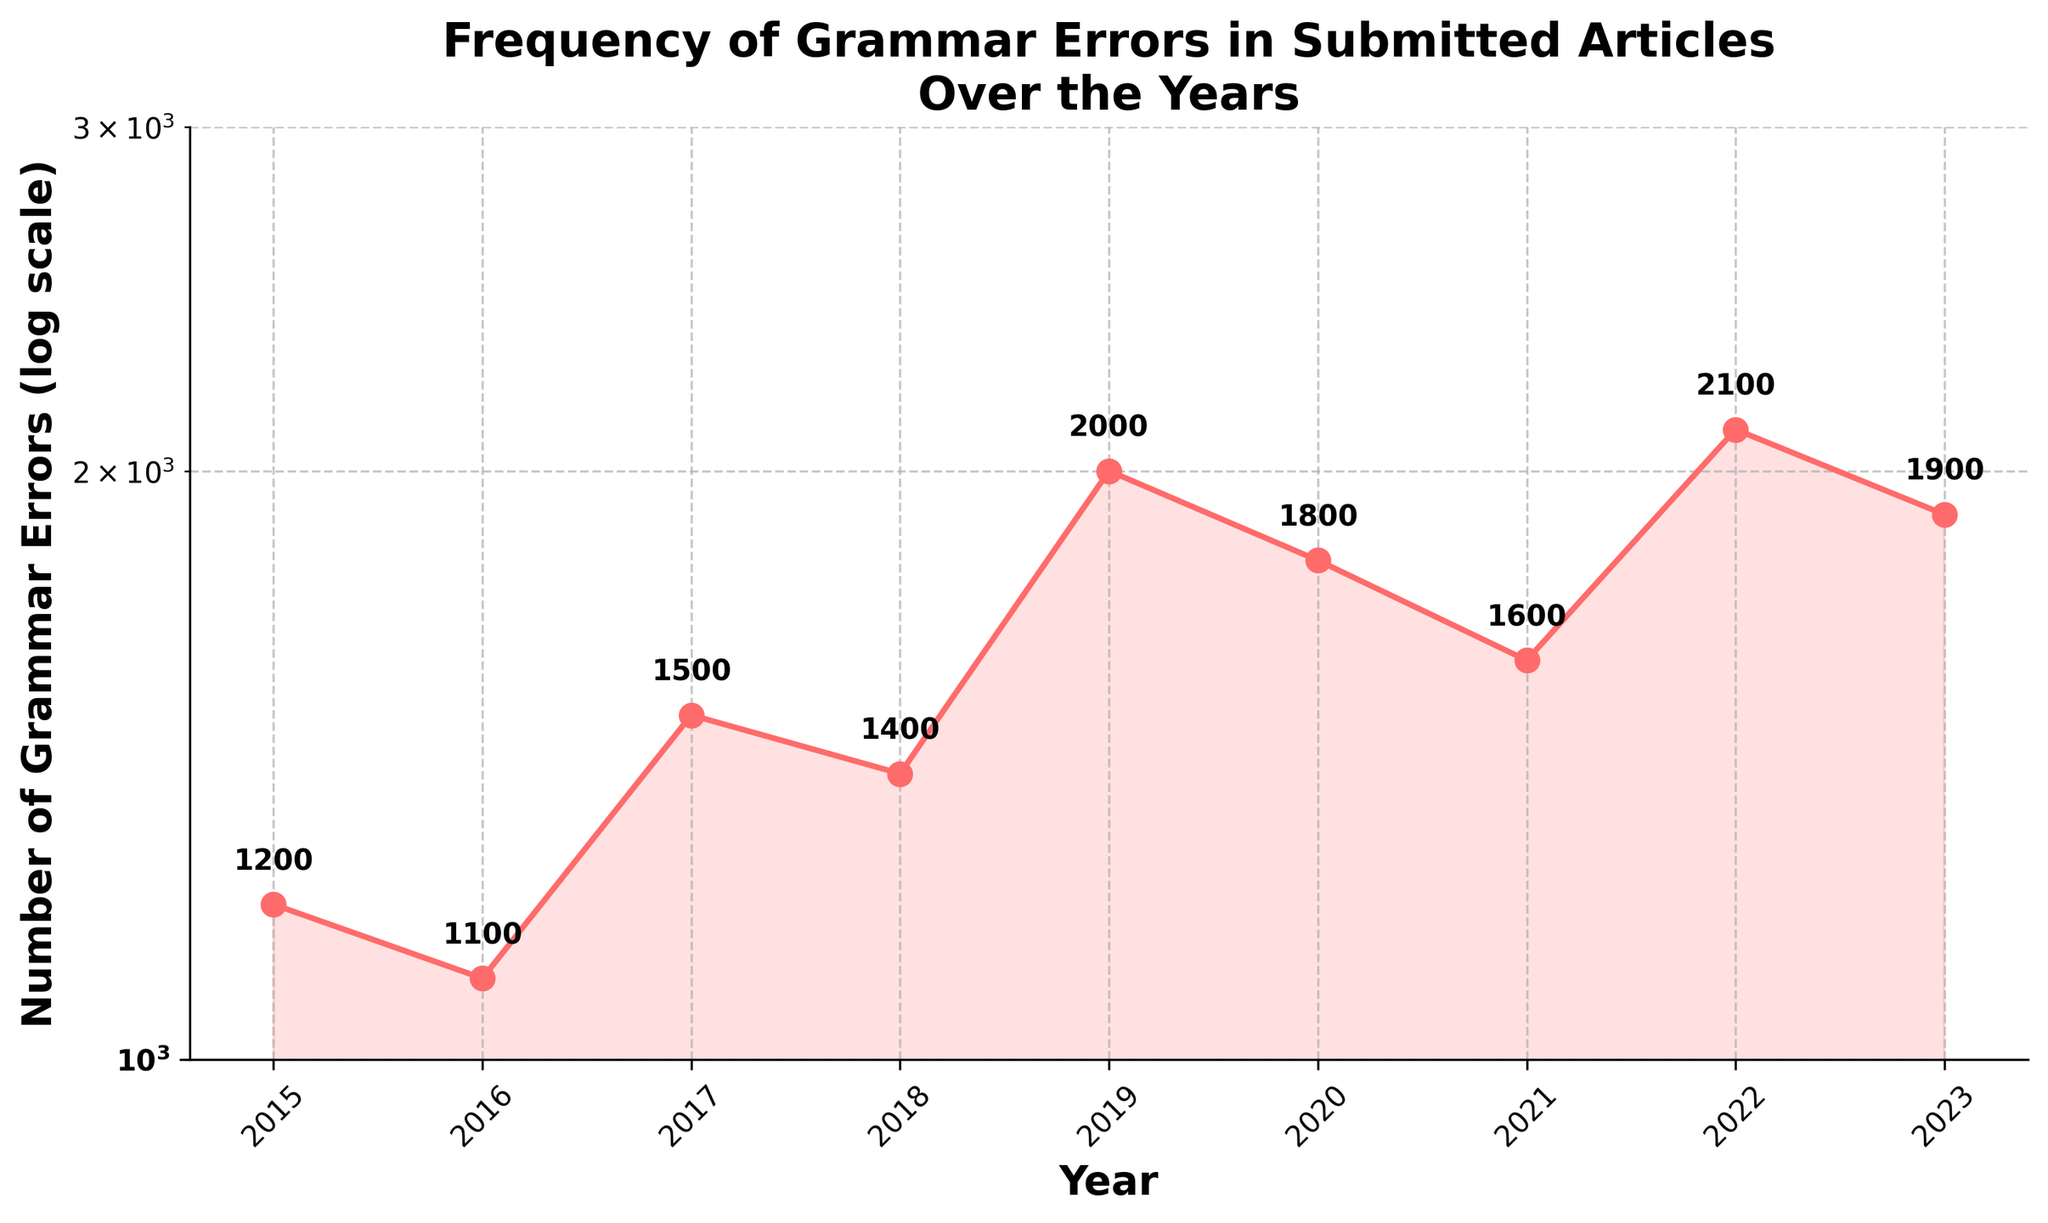What's the title of the figure? The title of the figure is displayed at the top, summarizing the content of the visual. Here, it is shown in bold for emphasis.
Answer: Frequency of Grammar Errors in Submitted Articles Over the Years What is the range of years represented in the plot? The range of years is provided by the x-axis which shows the specific years from start to end. They are sequential and clearly labeled below the x-axis line.
Answer: 2015 to 2023 How many grammar errors occurred in 2019? The 2019 data point is specifically labeled on the graph as every data point has an annotation showing the number of errors directly above the respective year.
Answer: 2000 Which year had the highest number of grammar errors? By inspecting the plotted points and their annotations, the year with the greatest numerical label indicates the peak in grammar errors.
Answer: 2022 What is the trend of grammar errors between 2019 and 2020? Observing the plotted line between these two years, one can see whether it ascends, descends, or stays flat based on the respective y-values. This section of the plot reveals whether there is an increase or decrease in errors.
Answer: Decreasing Calculate the average number of grammar errors over the years depicted. Compute the sum of all provided yearly error values and then divide by the total number of years represented to find the average. (1200 + 1100 + 1500 + 1400 + 2000 + 1800 + 1600 + 2100 + 1900) / 9
Answer: 1622.22 Is the plot on a linear or logarithmic scale? The nature of the y-axis indicates the type of scale used. The visible spacing and annotations suggest whether it's even (linear) or multiplicative (logarithmic), often also highlighted in the plot's labels.
Answer: Logarithmic How does the number of errors in 2015 compare with the number of errors in 2023? Analyze the annotations and compare the values for these two years. The comparison will indicate which year had more errors.
Answer: 2023 had more errors than 2015 What's the difference in the number of grammar errors between 2021 and 2022? Look at the annotations on the plot for these two years and subtract the value of 2021 from 2022 to get the difference.
Answer: 500 Which period saw the most significant increase in grammar errors, and by how much? Examine the intervals between consecutive years, identify where the steepest incline occurs by visual inspection or by comparing adjacent values, then calculate the increase. The most significant jump in values should be highlighted.
Answer: Between 2018 and 2019, with an increase of 600 